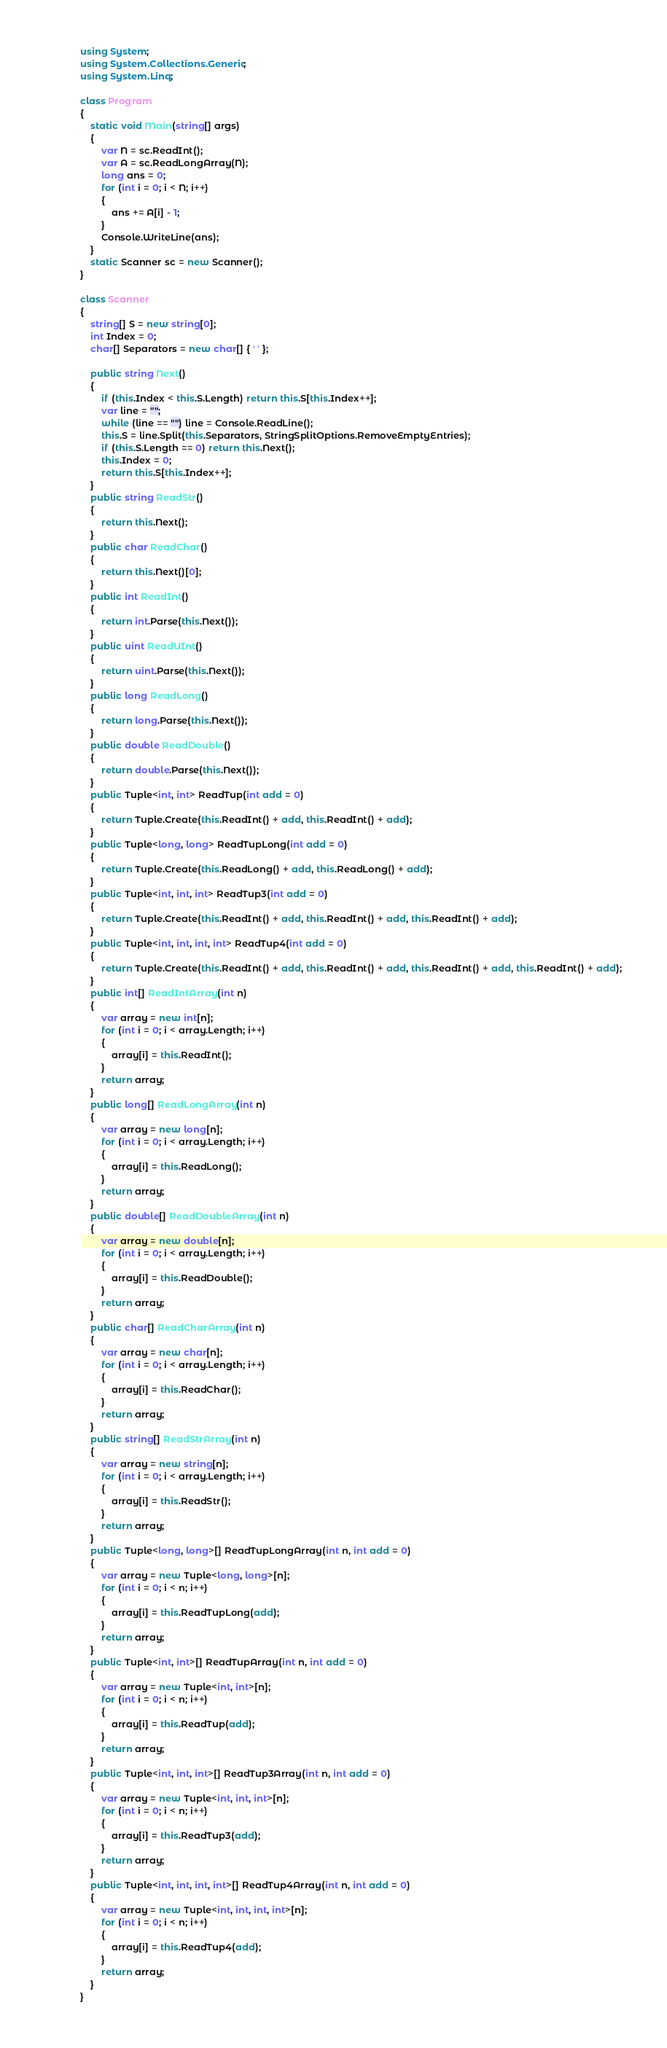<code> <loc_0><loc_0><loc_500><loc_500><_C#_>using System;
using System.Collections.Generic;
using System.Linq;

class Program
{
    static void Main(string[] args)
    {
        var N = sc.ReadInt();
        var A = sc.ReadLongArray(N);
        long ans = 0;
        for (int i = 0; i < N; i++)
        {
            ans += A[i] - 1;
        }
        Console.WriteLine(ans);
    }
    static Scanner sc = new Scanner();
}

class Scanner
{
    string[] S = new string[0];
    int Index = 0;
    char[] Separators = new char[] { ' ' };

    public string Next()
    {
        if (this.Index < this.S.Length) return this.S[this.Index++];
        var line = "";
        while (line == "") line = Console.ReadLine();
        this.S = line.Split(this.Separators, StringSplitOptions.RemoveEmptyEntries);
        if (this.S.Length == 0) return this.Next();
        this.Index = 0;
        return this.S[this.Index++];
    }
    public string ReadStr()
    {
        return this.Next();
    }
    public char ReadChar()
    {
        return this.Next()[0];
    }
    public int ReadInt()
    {
        return int.Parse(this.Next());
    }
    public uint ReadUInt()
    {
        return uint.Parse(this.Next());
    }
    public long ReadLong()
    {
        return long.Parse(this.Next());
    }
    public double ReadDouble()
    {
        return double.Parse(this.Next());
    }
    public Tuple<int, int> ReadTup(int add = 0)
    {
        return Tuple.Create(this.ReadInt() + add, this.ReadInt() + add);
    }
    public Tuple<long, long> ReadTupLong(int add = 0)
    {
        return Tuple.Create(this.ReadLong() + add, this.ReadLong() + add);
    }
    public Tuple<int, int, int> ReadTup3(int add = 0)
    {
        return Tuple.Create(this.ReadInt() + add, this.ReadInt() + add, this.ReadInt() + add);
    }
    public Tuple<int, int, int, int> ReadTup4(int add = 0)
    {
        return Tuple.Create(this.ReadInt() + add, this.ReadInt() + add, this.ReadInt() + add, this.ReadInt() + add);
    }
    public int[] ReadIntArray(int n)
    {
        var array = new int[n];
        for (int i = 0; i < array.Length; i++)
        {
            array[i] = this.ReadInt();
        }
        return array;
    }
    public long[] ReadLongArray(int n)
    {
        var array = new long[n];
        for (int i = 0; i < array.Length; i++)
        {
            array[i] = this.ReadLong();
        }
        return array;
    }
    public double[] ReadDoubleArray(int n)
    {
        var array = new double[n];
        for (int i = 0; i < array.Length; i++)
        {
            array[i] = this.ReadDouble();
        }
        return array;
    }
    public char[] ReadCharArray(int n)
    {
        var array = new char[n];
        for (int i = 0; i < array.Length; i++)
        {
            array[i] = this.ReadChar();
        }
        return array;
    }
    public string[] ReadStrArray(int n)
    {
        var array = new string[n];
        for (int i = 0; i < array.Length; i++)
        {
            array[i] = this.ReadStr();
        }
        return array;
    }
    public Tuple<long, long>[] ReadTupLongArray(int n, int add = 0)
    {
        var array = new Tuple<long, long>[n];
        for (int i = 0; i < n; i++)
        {
            array[i] = this.ReadTupLong(add);
        }
        return array;
    }
    public Tuple<int, int>[] ReadTupArray(int n, int add = 0)
    {
        var array = new Tuple<int, int>[n];
        for (int i = 0; i < n; i++)
        {
            array[i] = this.ReadTup(add);
        }
        return array;
    }
    public Tuple<int, int, int>[] ReadTup3Array(int n, int add = 0)
    {
        var array = new Tuple<int, int, int>[n];
        for (int i = 0; i < n; i++)
        {
            array[i] = this.ReadTup3(add);
        }
        return array;
    }
    public Tuple<int, int, int, int>[] ReadTup4Array(int n, int add = 0)
    {
        var array = new Tuple<int, int, int, int>[n];
        for (int i = 0; i < n; i++)
        {
            array[i] = this.ReadTup4(add);
        }
        return array;
    }
}
</code> 